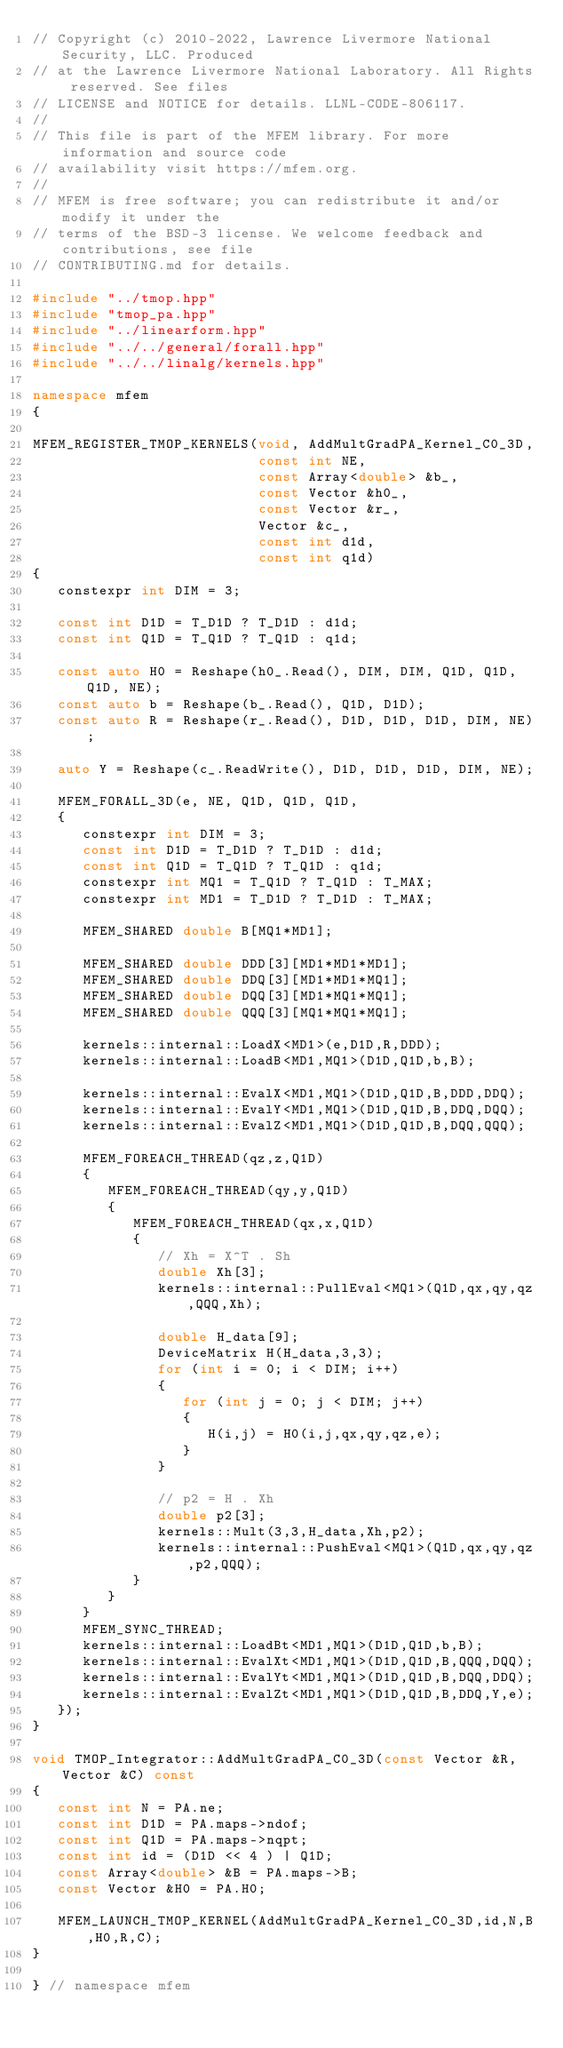<code> <loc_0><loc_0><loc_500><loc_500><_C++_>// Copyright (c) 2010-2022, Lawrence Livermore National Security, LLC. Produced
// at the Lawrence Livermore National Laboratory. All Rights reserved. See files
// LICENSE and NOTICE for details. LLNL-CODE-806117.
//
// This file is part of the MFEM library. For more information and source code
// availability visit https://mfem.org.
//
// MFEM is free software; you can redistribute it and/or modify it under the
// terms of the BSD-3 license. We welcome feedback and contributions, see file
// CONTRIBUTING.md for details.

#include "../tmop.hpp"
#include "tmop_pa.hpp"
#include "../linearform.hpp"
#include "../../general/forall.hpp"
#include "../../linalg/kernels.hpp"

namespace mfem
{

MFEM_REGISTER_TMOP_KERNELS(void, AddMultGradPA_Kernel_C0_3D,
                           const int NE,
                           const Array<double> &b_,
                           const Vector &h0_,
                           const Vector &r_,
                           Vector &c_,
                           const int d1d,
                           const int q1d)
{
   constexpr int DIM = 3;

   const int D1D = T_D1D ? T_D1D : d1d;
   const int Q1D = T_Q1D ? T_Q1D : q1d;

   const auto H0 = Reshape(h0_.Read(), DIM, DIM, Q1D, Q1D, Q1D, NE);
   const auto b = Reshape(b_.Read(), Q1D, D1D);
   const auto R = Reshape(r_.Read(), D1D, D1D, D1D, DIM, NE);

   auto Y = Reshape(c_.ReadWrite(), D1D, D1D, D1D, DIM, NE);

   MFEM_FORALL_3D(e, NE, Q1D, Q1D, Q1D,
   {
      constexpr int DIM = 3;
      const int D1D = T_D1D ? T_D1D : d1d;
      const int Q1D = T_Q1D ? T_Q1D : q1d;
      constexpr int MQ1 = T_Q1D ? T_Q1D : T_MAX;
      constexpr int MD1 = T_D1D ? T_D1D : T_MAX;

      MFEM_SHARED double B[MQ1*MD1];

      MFEM_SHARED double DDD[3][MD1*MD1*MD1];
      MFEM_SHARED double DDQ[3][MD1*MD1*MQ1];
      MFEM_SHARED double DQQ[3][MD1*MQ1*MQ1];
      MFEM_SHARED double QQQ[3][MQ1*MQ1*MQ1];

      kernels::internal::LoadX<MD1>(e,D1D,R,DDD);
      kernels::internal::LoadB<MD1,MQ1>(D1D,Q1D,b,B);

      kernels::internal::EvalX<MD1,MQ1>(D1D,Q1D,B,DDD,DDQ);
      kernels::internal::EvalY<MD1,MQ1>(D1D,Q1D,B,DDQ,DQQ);
      kernels::internal::EvalZ<MD1,MQ1>(D1D,Q1D,B,DQQ,QQQ);

      MFEM_FOREACH_THREAD(qz,z,Q1D)
      {
         MFEM_FOREACH_THREAD(qy,y,Q1D)
         {
            MFEM_FOREACH_THREAD(qx,x,Q1D)
            {
               // Xh = X^T . Sh
               double Xh[3];
               kernels::internal::PullEval<MQ1>(Q1D,qx,qy,qz,QQQ,Xh);

               double H_data[9];
               DeviceMatrix H(H_data,3,3);
               for (int i = 0; i < DIM; i++)
               {
                  for (int j = 0; j < DIM; j++)
                  {
                     H(i,j) = H0(i,j,qx,qy,qz,e);
                  }
               }

               // p2 = H . Xh
               double p2[3];
               kernels::Mult(3,3,H_data,Xh,p2);
               kernels::internal::PushEval<MQ1>(Q1D,qx,qy,qz,p2,QQQ);
            }
         }
      }
      MFEM_SYNC_THREAD;
      kernels::internal::LoadBt<MD1,MQ1>(D1D,Q1D,b,B);
      kernels::internal::EvalXt<MD1,MQ1>(D1D,Q1D,B,QQQ,DQQ);
      kernels::internal::EvalYt<MD1,MQ1>(D1D,Q1D,B,DQQ,DDQ);
      kernels::internal::EvalZt<MD1,MQ1>(D1D,Q1D,B,DDQ,Y,e);
   });
}

void TMOP_Integrator::AddMultGradPA_C0_3D(const Vector &R, Vector &C) const
{
   const int N = PA.ne;
   const int D1D = PA.maps->ndof;
   const int Q1D = PA.maps->nqpt;
   const int id = (D1D << 4 ) | Q1D;
   const Array<double> &B = PA.maps->B;
   const Vector &H0 = PA.H0;

   MFEM_LAUNCH_TMOP_KERNEL(AddMultGradPA_Kernel_C0_3D,id,N,B,H0,R,C);
}

} // namespace mfem
</code> 